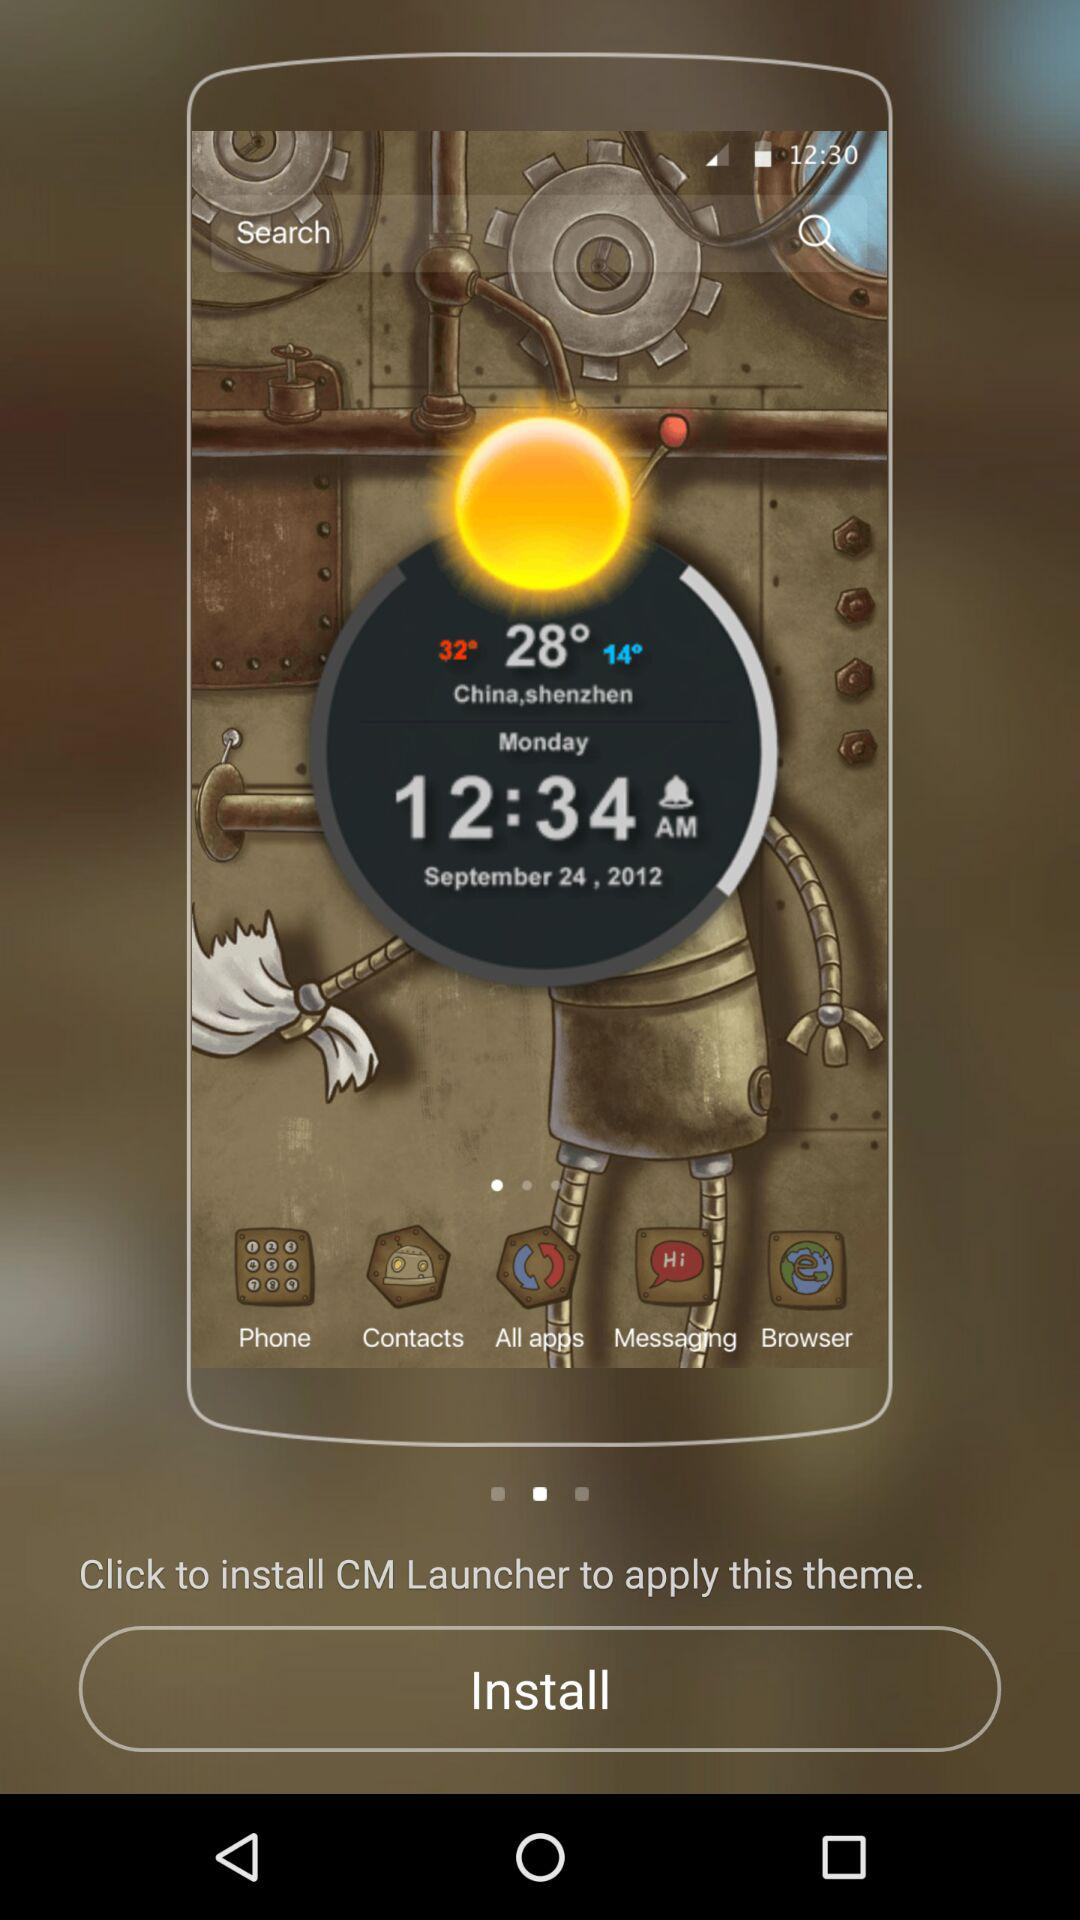What's the weather?
When the provided information is insufficient, respond with <no answer>. <no answer> 